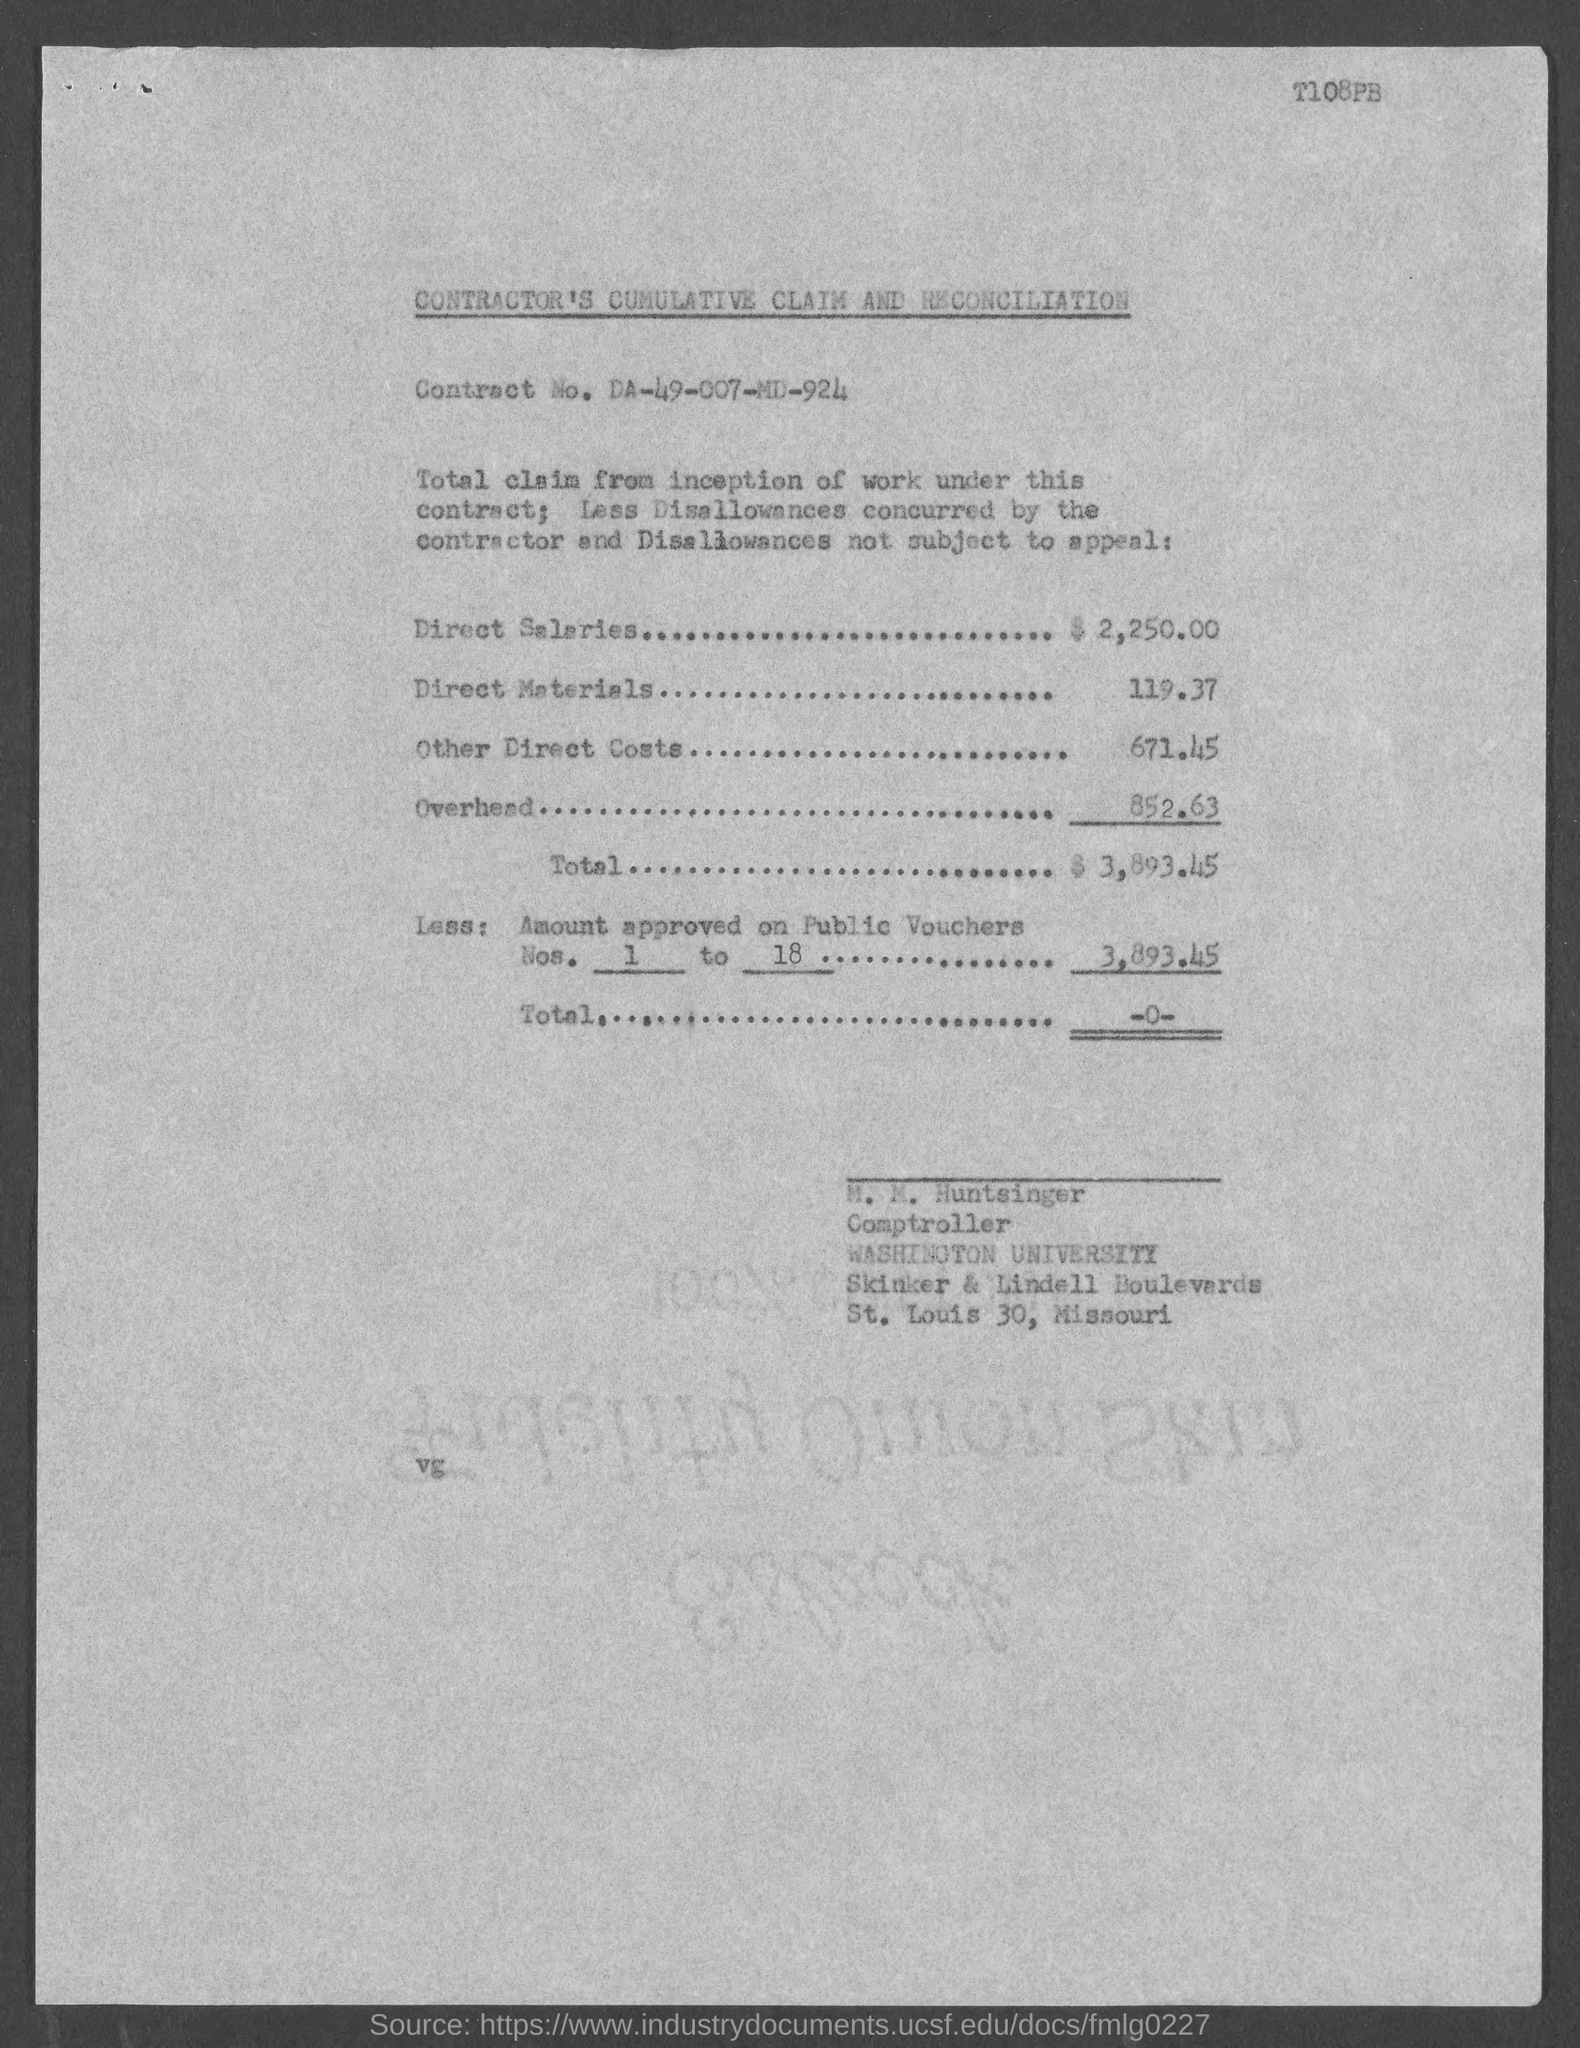What is the code mentioned at the top of the page?
Your response must be concise. T108PB. What is the document title?
Give a very brief answer. Contractor's cumulative claim and reconciliation. What is the Contract No.?
Make the answer very short. Da-49-007-md-924. What is the amount of direct salaries?
Your response must be concise. $ 2,250.00. Who is the Comptroller?
Your answer should be very brief. M. M. Huntsinger. 